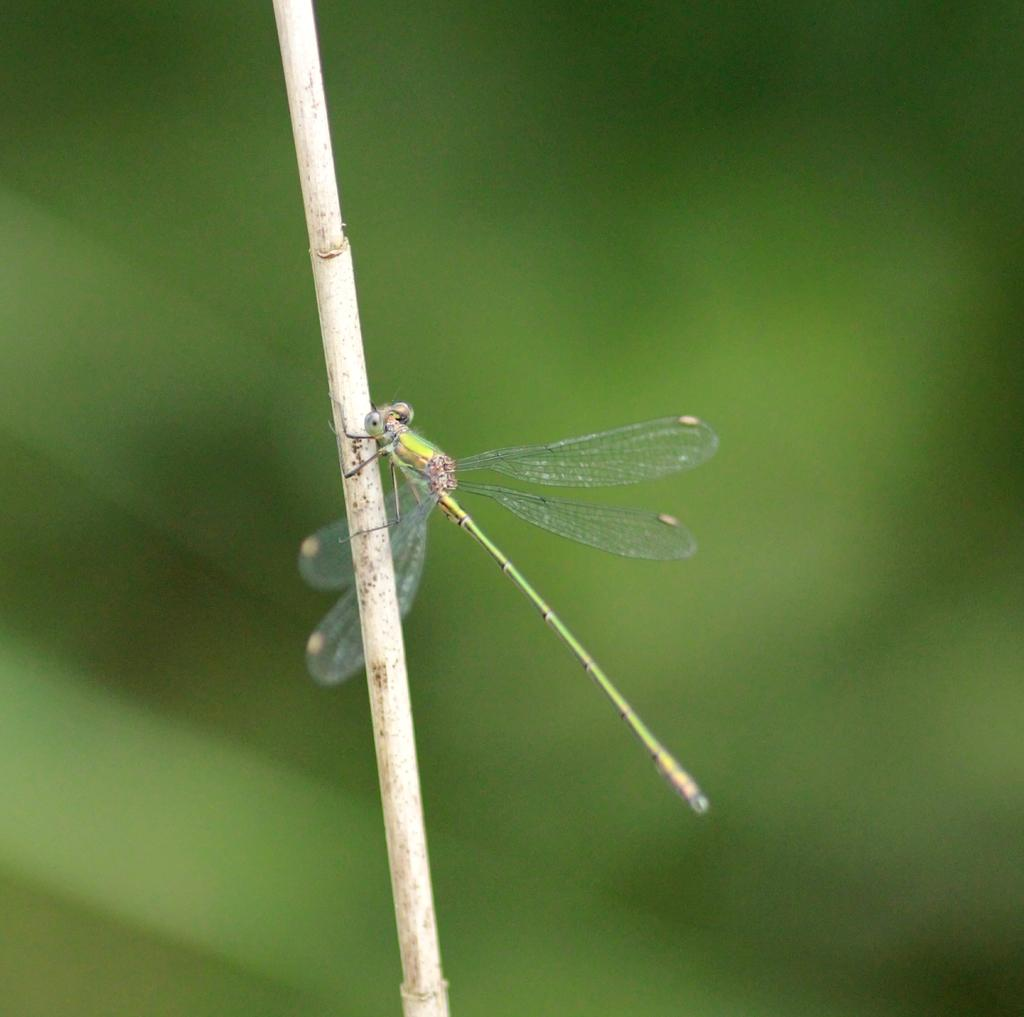What type of insect is present in the image? There is a dragonfly in the image. Can you describe the background of the image? The background of the image is blurry. What type of humor is being displayed by the dragonfly in the image? There is no indication of humor in the image, as it features a dragonfly and a blurry background. 